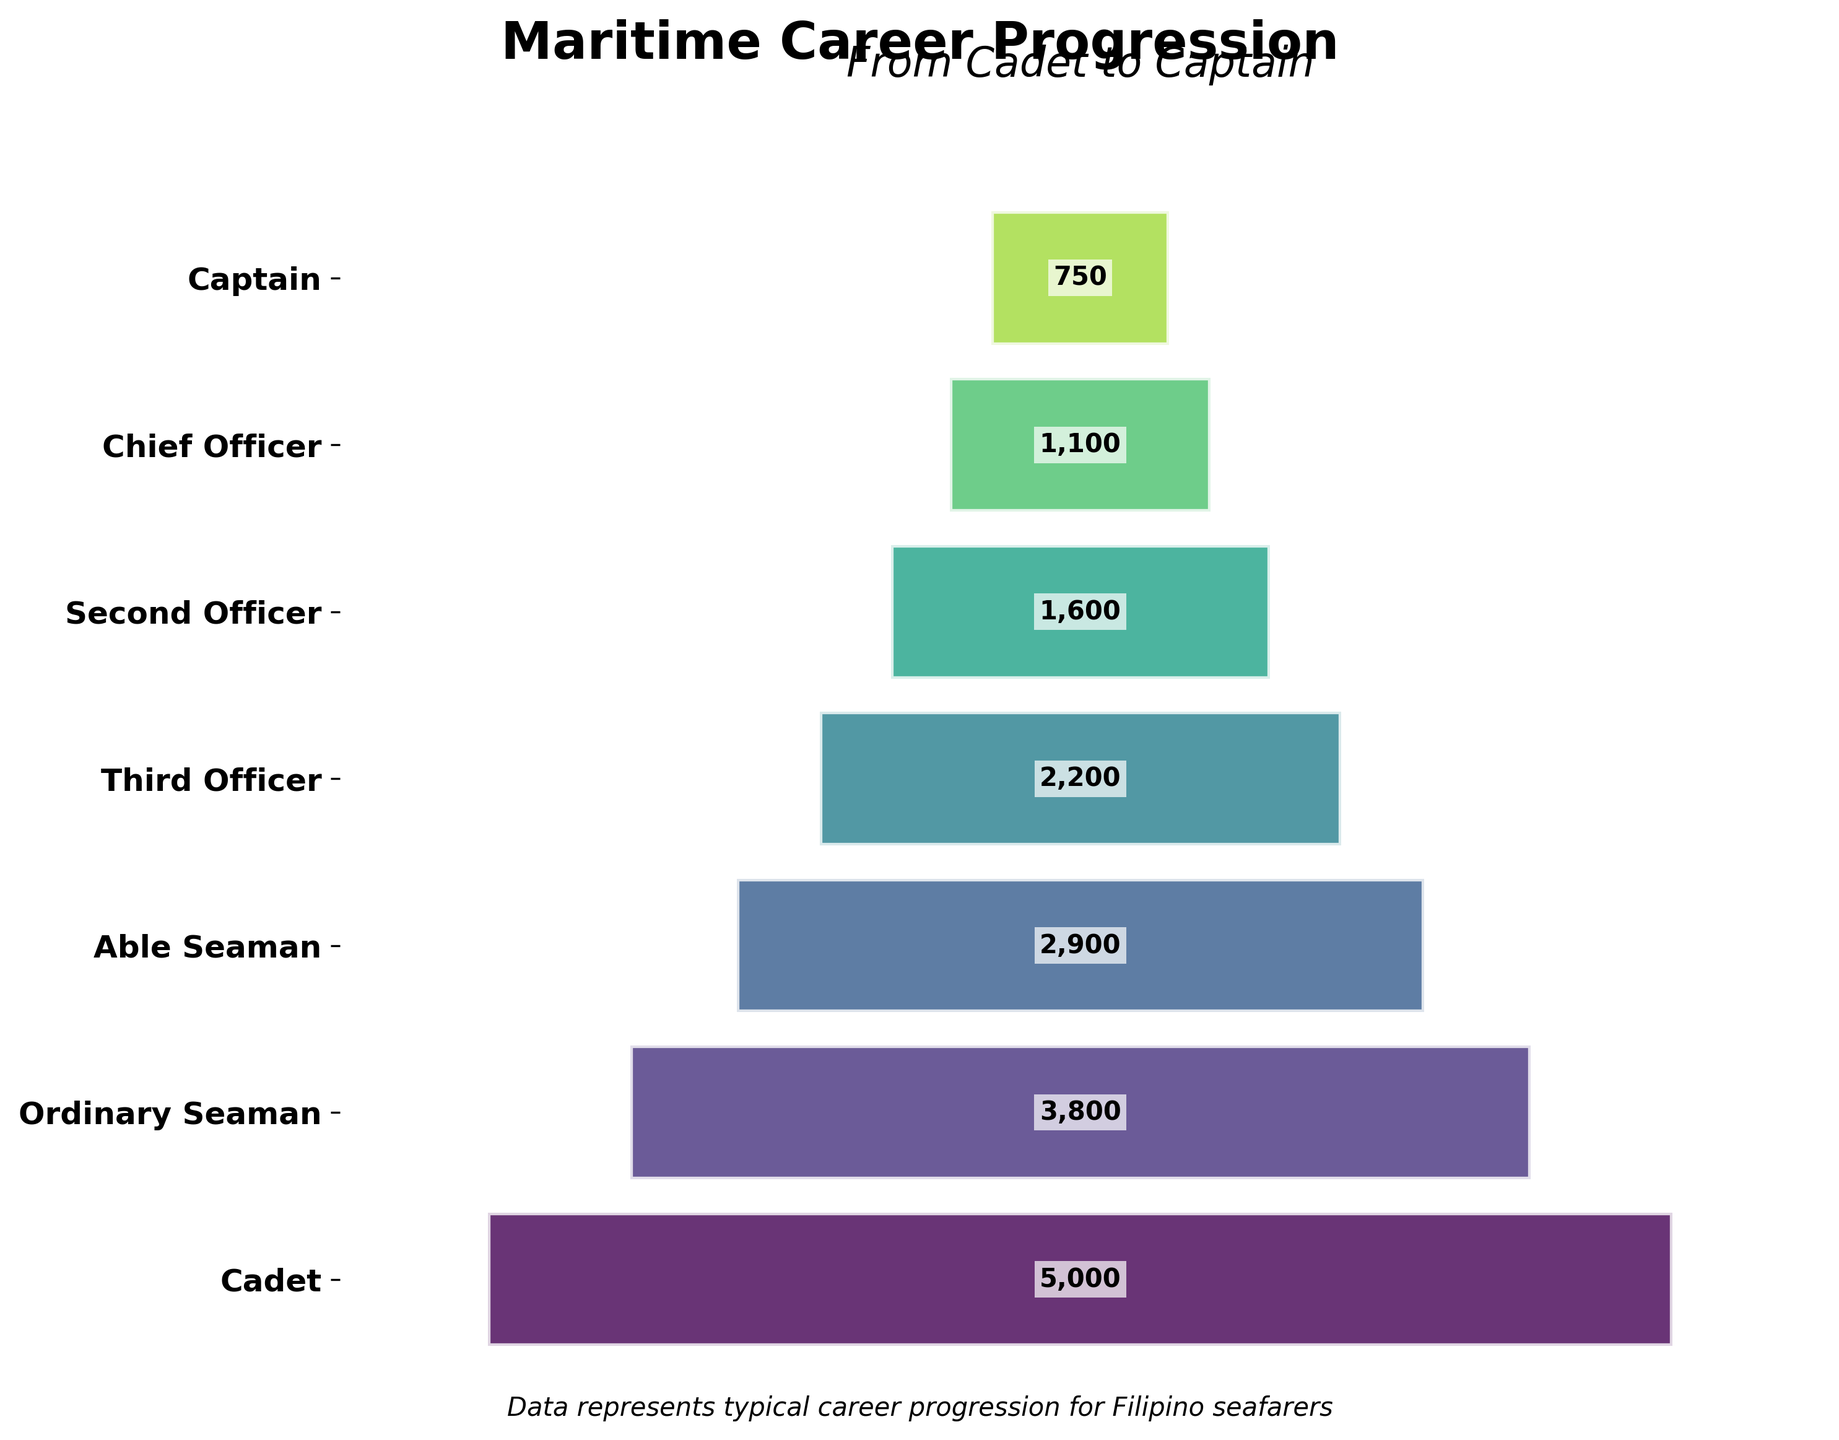What is the title of the chart? The title of the chart is usually found at the top and gives an overview of the figure. The main title in bold letters is "Maritime Career Progression".
Answer: Maritime Career Progression What is the subtitle of the chart? The subtitle of the chart is beneath the main title and typically provides additional context. The subtitle in italic letters is "From Cadet to Captain".
Answer: From Cadet to Captain How many stages are displayed in the funnel chart? The number of stages can be counted by examining the y-axis labels or the distinct segments of the funnel. There are 7 stages listed from top to bottom.
Answer: 7 Which stage has the highest number of seafarers? The top segment in a funnel chart usually has the highest value as the funnel narrows downwards. The top segment, labeled "Cadet," signifies the stage with the highest number, which is 5000 seafarers.
Answer: Cadet Which stage has the fewest number of seafarers? The bottom segment in a funnel chart usually has the smallest value as the funnel narrows downwards. The bottom segment, labeled "Captain," signifies the stage with the fewest number, which is 750 seafarers.
Answer: Captain How many seafarers progress from Second Officer to Chief Officer? To find the number of seafarers moving from Second Officer to Chief Officer, subtract the number at the Chief Officer stage from the number at the Second Officer stage. The values are 1600 for Second Officer and 1100 for Chief Officer. 1600 - 1100 = 500
Answer: 500 What is the total number of seafarers from Cadet to Able Seaman? Add the number of seafarers at each stage from Cadet to Able Seaman: 5000 (Cadet) + 3800 (Ordinary Seaman) + 2900 (Able Seaman). So, 5000 + 3800 + 2900 = 11700
Answer: 11700 Which stages have a number of seafarers greater than 2000? Identify the stages where the number of seafarers is greater than 2000 by looking at the values for each stage: Cadet (5000), Ordinary Seaman (3800), Able Seaman (2900), and Third Officer (2200) are all greater than 2000.
Answer: Cadet, Ordinary Seaman, Able Seaman, Third Officer What is the difference in the number of seafarers between Third Officer and Captain? Subtract the number of seafarers at the Captain stage from the number at the Third Officer stage. The values are 2200 for Third Officer and 750 for Captain. 2200 - 750 = 1450
Answer: 1450 How does the size of the "Second Officer" segment compare to the "Third Officer" segment? Comparison requires evaluating the width of the respective segments. The "Second Officer" segment is narrower than the "Third Officer" segment because there are fewer seafarers in the Second Officer stage (1600) compared to the Third Officer stage (2200).
Answer: Narrows down from Third Officer to Second Officer 